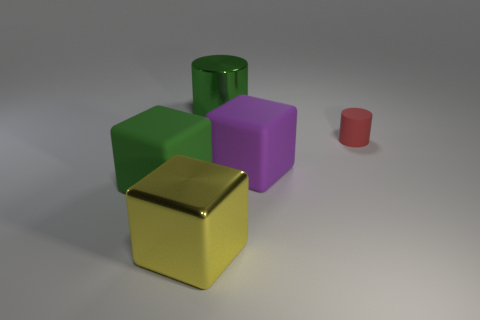How many large objects are red cylinders or green rubber things?
Give a very brief answer. 1. What material is the purple cube?
Provide a short and direct response. Rubber. What number of other objects are there of the same shape as the purple thing?
Offer a very short reply. 2. What size is the green cylinder?
Provide a short and direct response. Large. How big is the thing that is both to the left of the purple thing and to the right of the large yellow block?
Your response must be concise. Large. There is a large shiny thing behind the tiny red matte object; what shape is it?
Make the answer very short. Cylinder. Does the purple block have the same material as the thing that is behind the small red matte thing?
Give a very brief answer. No. Is the shape of the green matte object the same as the big green metal object?
Your answer should be very brief. No. What is the material of the other small object that is the same shape as the green metal thing?
Make the answer very short. Rubber. There is a large object that is both in front of the large green shiny cylinder and behind the large green rubber cube; what is its color?
Offer a terse response. Purple. 